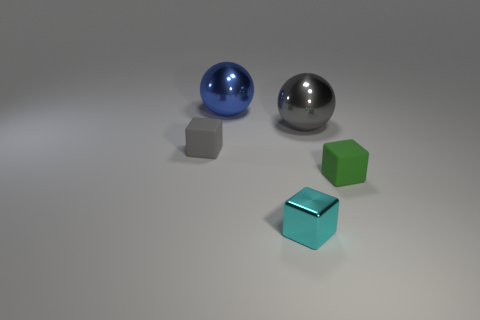There is a gray object that is behind the gray rubber object; what size is it?
Provide a succinct answer. Large. There is a small matte block in front of the matte cube that is left of the small green thing; are there any gray cubes behind it?
Your response must be concise. Yes. What number of cylinders are big gray metal things or gray things?
Offer a terse response. 0. The large object right of the large ball behind the big gray metallic thing is what shape?
Your answer should be very brief. Sphere. There is a rubber block that is right of the big metal object that is to the left of the object that is in front of the tiny green rubber thing; what size is it?
Offer a terse response. Small. Is the cyan shiny block the same size as the gray metallic ball?
Make the answer very short. No. How many things are either tiny cyan cubes or large blue objects?
Give a very brief answer. 2. What size is the gray thing that is behind the block on the left side of the blue shiny ball?
Your answer should be compact. Large. The green thing has what size?
Provide a succinct answer. Small. The object that is to the right of the small cyan shiny block and to the left of the small green thing has what shape?
Your answer should be very brief. Sphere. 